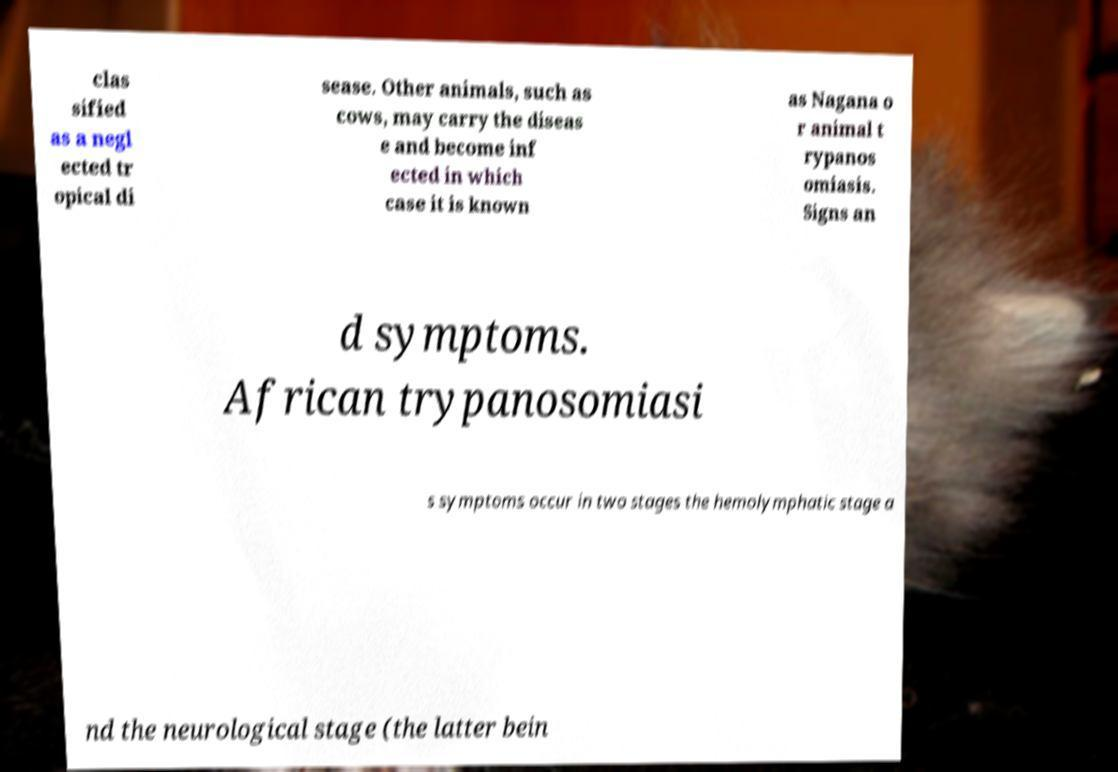There's text embedded in this image that I need extracted. Can you transcribe it verbatim? clas sified as a negl ected tr opical di sease. Other animals, such as cows, may carry the diseas e and become inf ected in which case it is known as Nagana o r animal t rypanos omiasis. Signs an d symptoms. African trypanosomiasi s symptoms occur in two stages the hemolymphatic stage a nd the neurological stage (the latter bein 